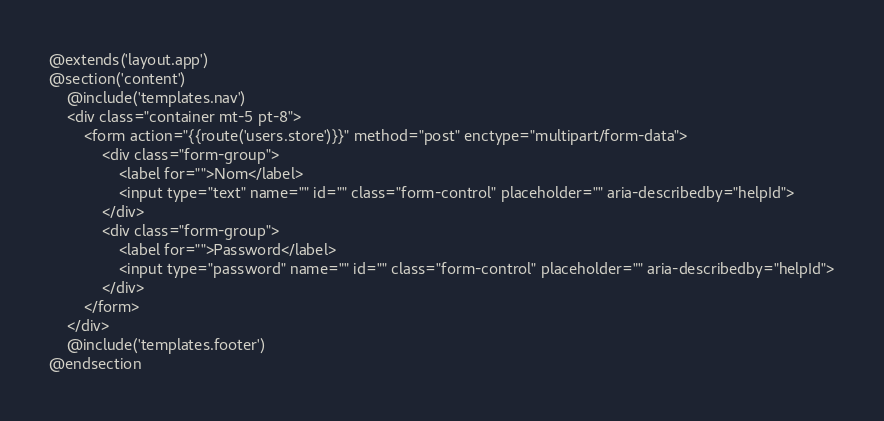Convert code to text. <code><loc_0><loc_0><loc_500><loc_500><_PHP_>@extends('layout.app')
@section('content')
    @include('templates.nav')
    <div class="container mt-5 pt-8">
        <form action="{{route('users.store')}}" method="post" enctype="multipart/form-data">
            <div class="form-group">
                <label for="">Nom</label>
                <input type="text" name="" id="" class="form-control" placeholder="" aria-describedby="helpId">
            </div>
            <div class="form-group">
                <label for="">Password</label>
                <input type="password" name="" id="" class="form-control" placeholder="" aria-describedby="helpId">
            </div>
        </form>
    </div>
    @include('templates.footer')
@endsection</code> 